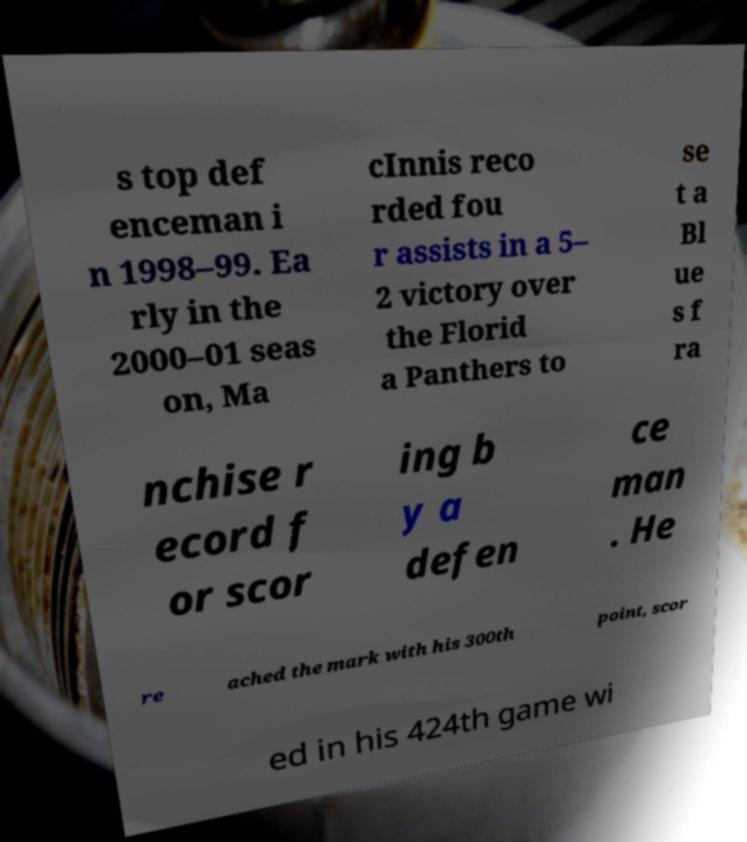Please read and relay the text visible in this image. What does it say? s top def enceman i n 1998–99. Ea rly in the 2000–01 seas on, Ma cInnis reco rded fou r assists in a 5– 2 victory over the Florid a Panthers to se t a Bl ue s f ra nchise r ecord f or scor ing b y a defen ce man . He re ached the mark with his 300th point, scor ed in his 424th game wi 